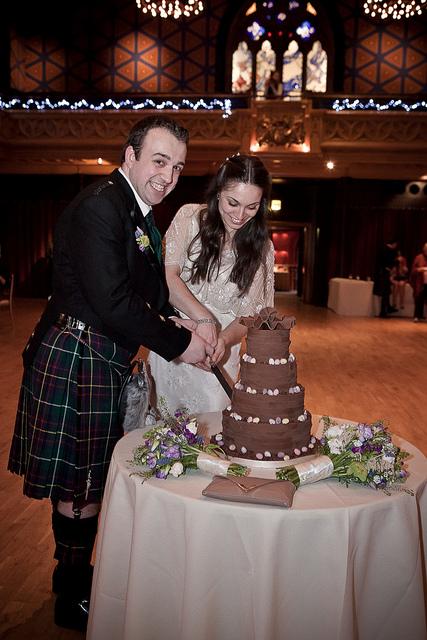Is this a wedding?
Keep it brief. Yes. What are they cutting?
Be succinct. Cake. What does the man wear to denote his culture?
Give a very brief answer. Kilt. 